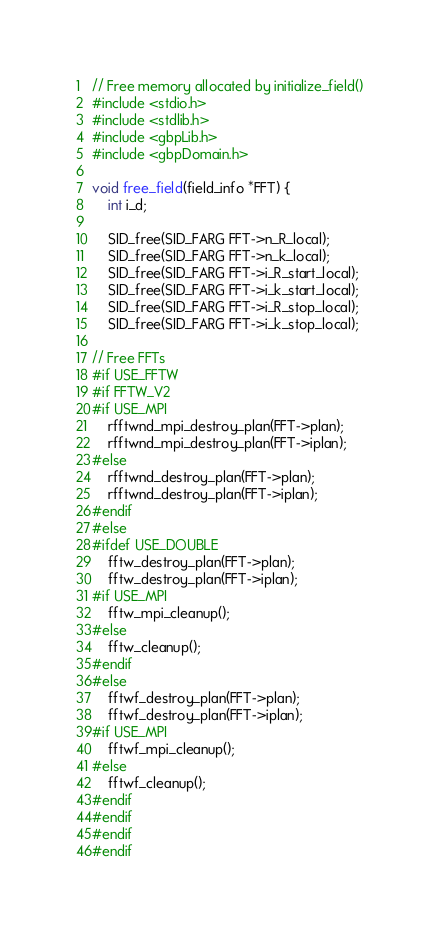Convert code to text. <code><loc_0><loc_0><loc_500><loc_500><_C_>// Free memory allocated by initialize_field()
#include <stdio.h>
#include <stdlib.h>
#include <gbpLib.h>
#include <gbpDomain.h>

void free_field(field_info *FFT) {
    int i_d;

    SID_free(SID_FARG FFT->n_R_local);
    SID_free(SID_FARG FFT->n_k_local);
    SID_free(SID_FARG FFT->i_R_start_local);
    SID_free(SID_FARG FFT->i_k_start_local);
    SID_free(SID_FARG FFT->i_R_stop_local);
    SID_free(SID_FARG FFT->i_k_stop_local);

// Free FFTs
#if USE_FFTW
#if FFTW_V2
#if USE_MPI
    rfftwnd_mpi_destroy_plan(FFT->plan);
    rfftwnd_mpi_destroy_plan(FFT->iplan);
#else
    rfftwnd_destroy_plan(FFT->plan);
    rfftwnd_destroy_plan(FFT->iplan);
#endif
#else
#ifdef USE_DOUBLE
    fftw_destroy_plan(FFT->plan);
    fftw_destroy_plan(FFT->iplan);
#if USE_MPI
    fftw_mpi_cleanup();
#else
    fftw_cleanup();
#endif
#else
    fftwf_destroy_plan(FFT->plan);
    fftwf_destroy_plan(FFT->iplan);
#if USE_MPI
    fftwf_mpi_cleanup();
#else
    fftwf_cleanup();
#endif
#endif
#endif
#endif
</code> 